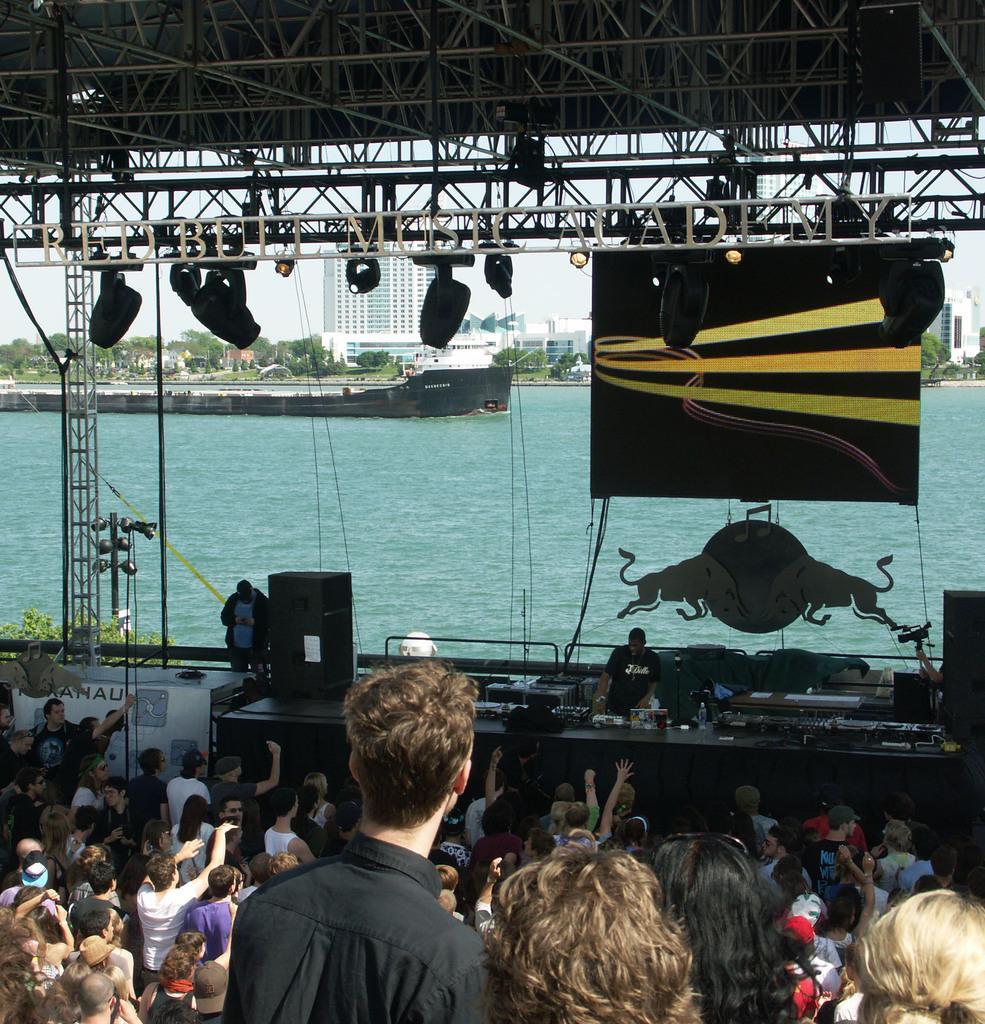Can you describe this image briefly? In this picture we can see a group of people standing, banner, speakers, lights, buildings, trees and a boat on water and in the background we can see the sky. 